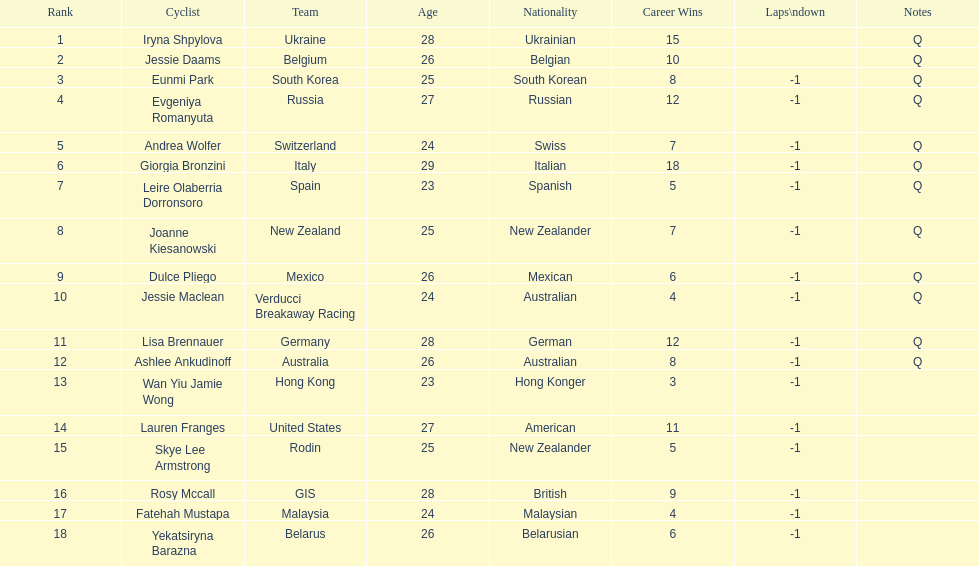Who was the first competitor to finish the race a lap behind? Eunmi Park. 